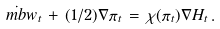<formula> <loc_0><loc_0><loc_500><loc_500>\dot { \ m b w } _ { t } \, + \, ( 1 / 2 ) \nabla \pi _ { t } \, = \, \chi ( \pi _ { t } ) \nabla H _ { t } \, .</formula> 